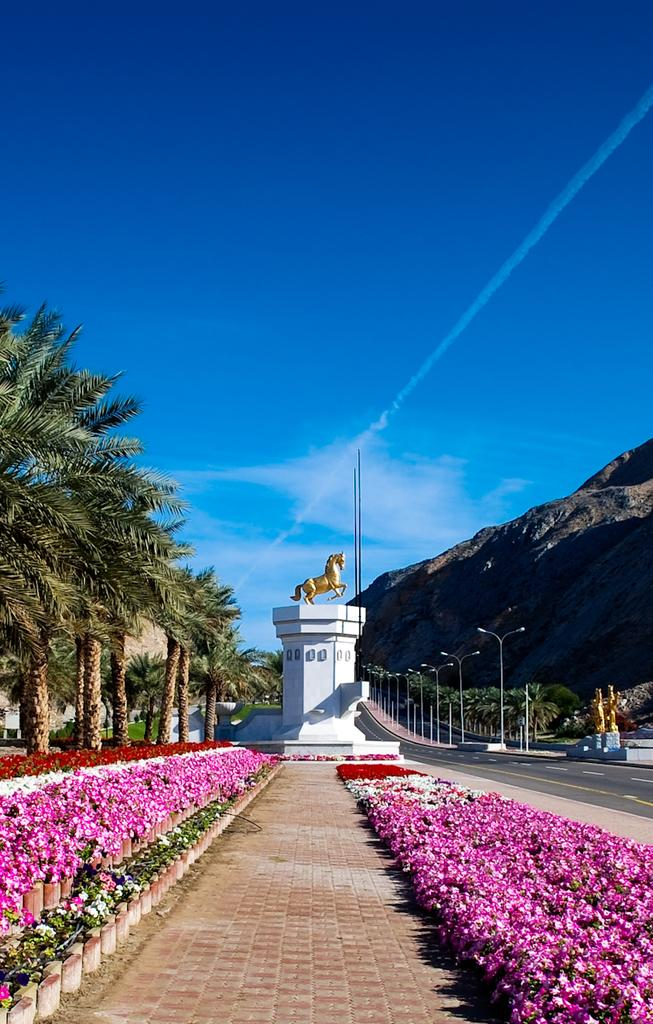What type of flowers can be seen in the image? There are pink color flowers in the image. What can be found along the pathway in the image? There is a horse statue along the pathway in the image. What type of vegetation is present in the image? There are trees in the image. What structures are present to provide light in the image? There are light poles in the image. What type of landscape feature is visible in the image? There are hills in the image. What is the color of the sky in the background of the image? The sky is blue in the background of the image. What can be seen in the sky in the image? There are clouds in the sky. Can you tell me how many mint leaves are on the horse statue in the image? There are no mint leaves present on the horse statue in the image. What type of jail can be seen in the background of the image? There is no jail present in the image; it features a blue sky with clouds. 